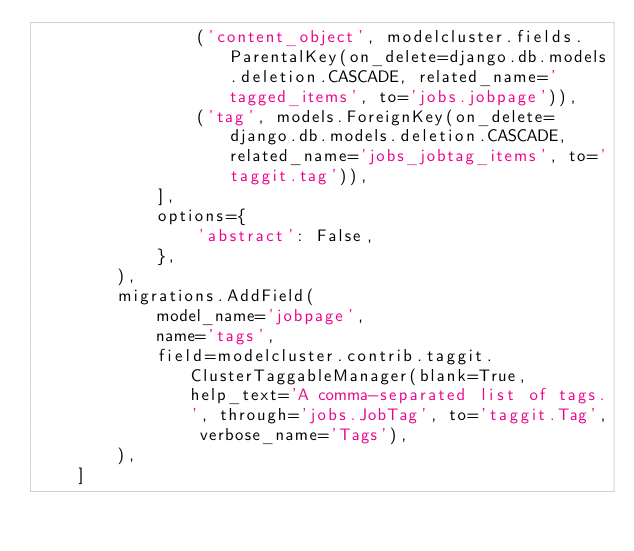<code> <loc_0><loc_0><loc_500><loc_500><_Python_>                ('content_object', modelcluster.fields.ParentalKey(on_delete=django.db.models.deletion.CASCADE, related_name='tagged_items', to='jobs.jobpage')),
                ('tag', models.ForeignKey(on_delete=django.db.models.deletion.CASCADE, related_name='jobs_jobtag_items', to='taggit.tag')),
            ],
            options={
                'abstract': False,
            },
        ),
        migrations.AddField(
            model_name='jobpage',
            name='tags',
            field=modelcluster.contrib.taggit.ClusterTaggableManager(blank=True, help_text='A comma-separated list of tags.', through='jobs.JobTag', to='taggit.Tag', verbose_name='Tags'),
        ),
    ]
</code> 